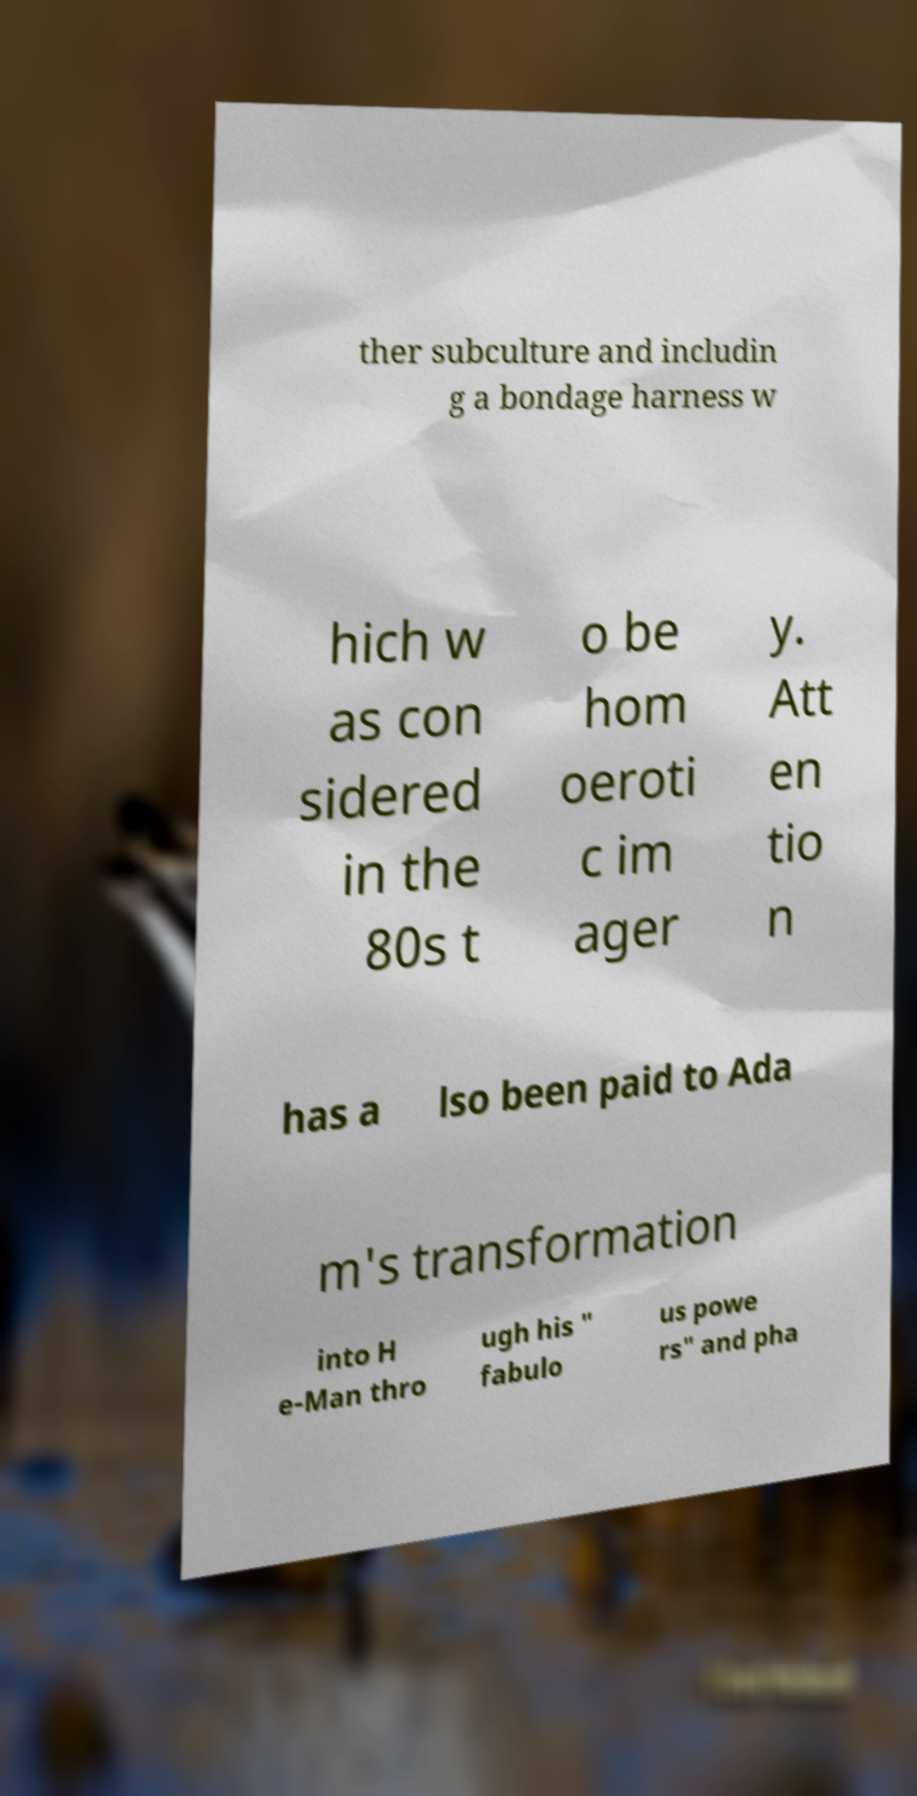For documentation purposes, I need the text within this image transcribed. Could you provide that? ther subculture and includin g a bondage harness w hich w as con sidered in the 80s t o be hom oeroti c im ager y. Att en tio n has a lso been paid to Ada m's transformation into H e-Man thro ugh his " fabulo us powe rs" and pha 